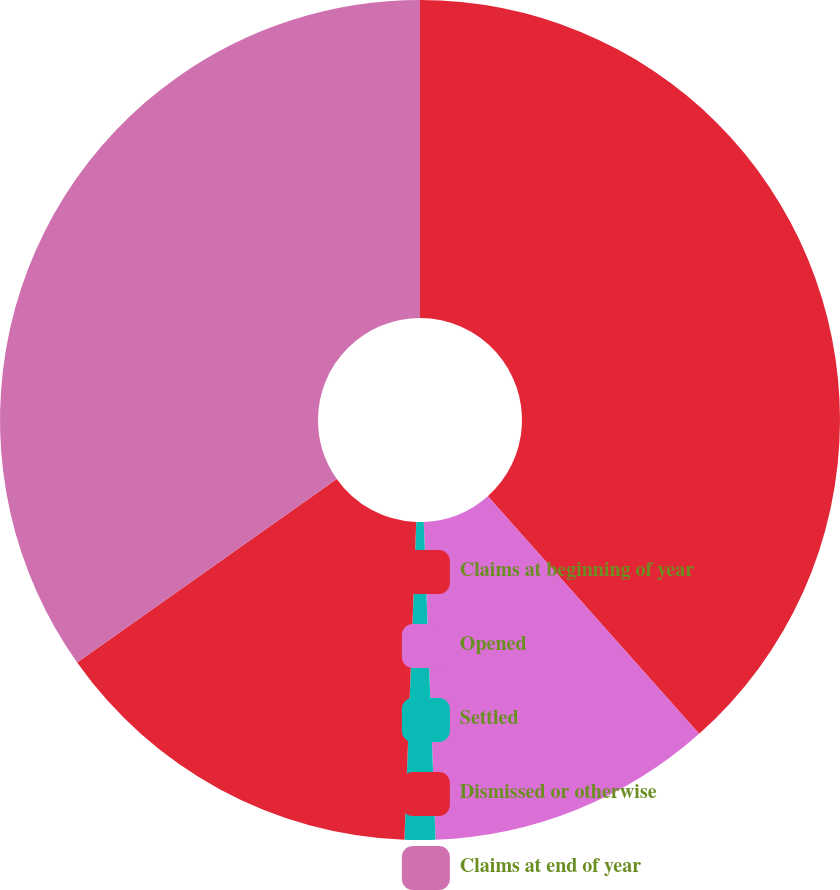<chart> <loc_0><loc_0><loc_500><loc_500><pie_chart><fcel>Claims at beginning of year<fcel>Opened<fcel>Settled<fcel>Dismissed or otherwise<fcel>Claims at end of year<nl><fcel>38.43%<fcel>10.98%<fcel>1.18%<fcel>14.61%<fcel>34.8%<nl></chart> 